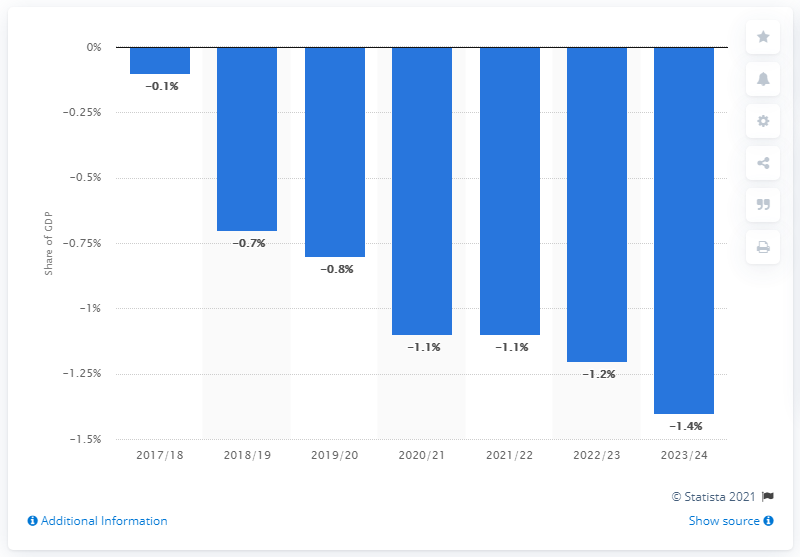Can you discuss how the budget deficit might impact the UK economy? Certainly, a budget deficit occurs when a government's expenditures exceed its revenues, necessitating borrowing to cover the shortfall. Persistent deficits can lead to accumulations of public debt, potentially resulting in higher interest rates as the risk perception among lenders grows. This can crowd out private investment, as businesses may find it more expensive to borrow. In contrast, deficit spending can also stimulate economic growth, especially if spent on infrastructure, education, or other productive investments. However, there are long-term sustainability concerns, such as the obligation to service the debt, which can constrain future government spending and policy options. 